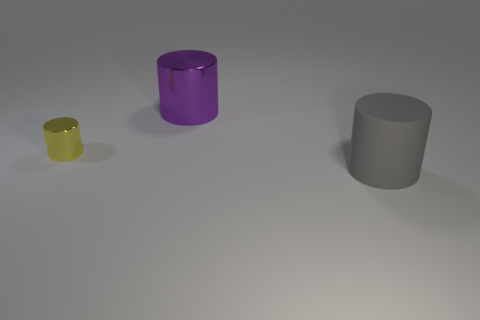Subtract all brown cylinders. Subtract all purple blocks. How many cylinders are left? 3 Add 2 large gray things. How many objects exist? 5 Subtract 0 red balls. How many objects are left? 3 Subtract all blue things. Subtract all gray cylinders. How many objects are left? 2 Add 1 small cylinders. How many small cylinders are left? 2 Add 1 rubber balls. How many rubber balls exist? 1 